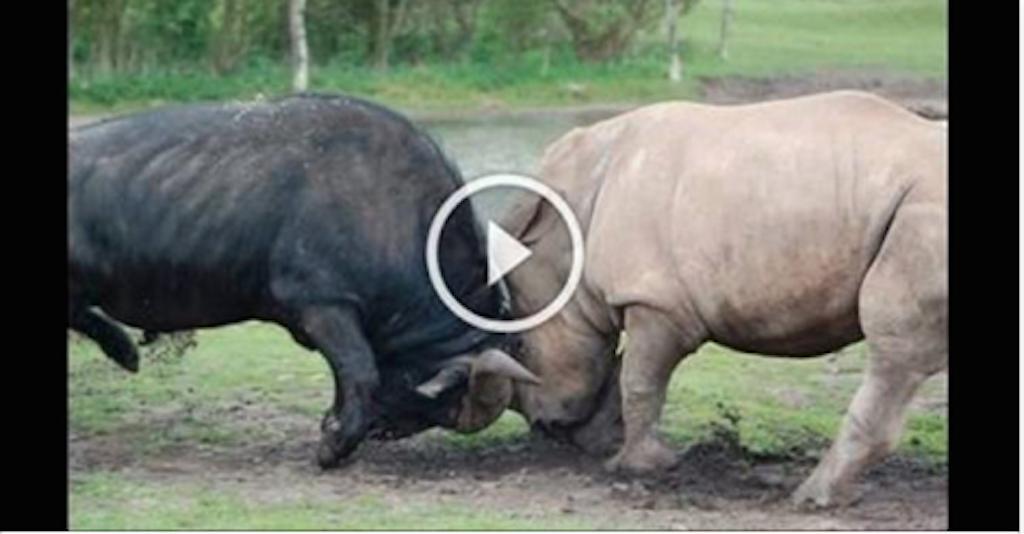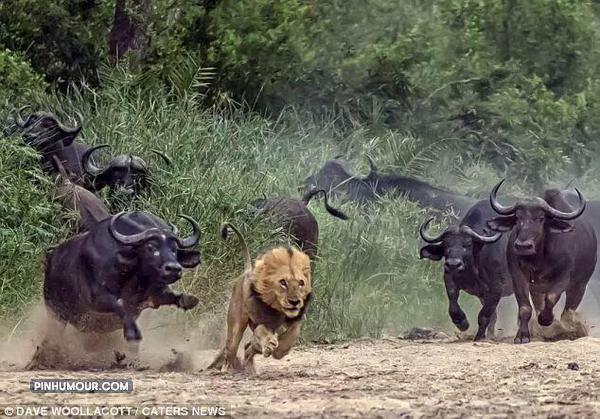The first image is the image on the left, the second image is the image on the right. Given the left and right images, does the statement "In one of the images, the wildebeest are chasing the lion." hold true? Answer yes or no. Yes. 